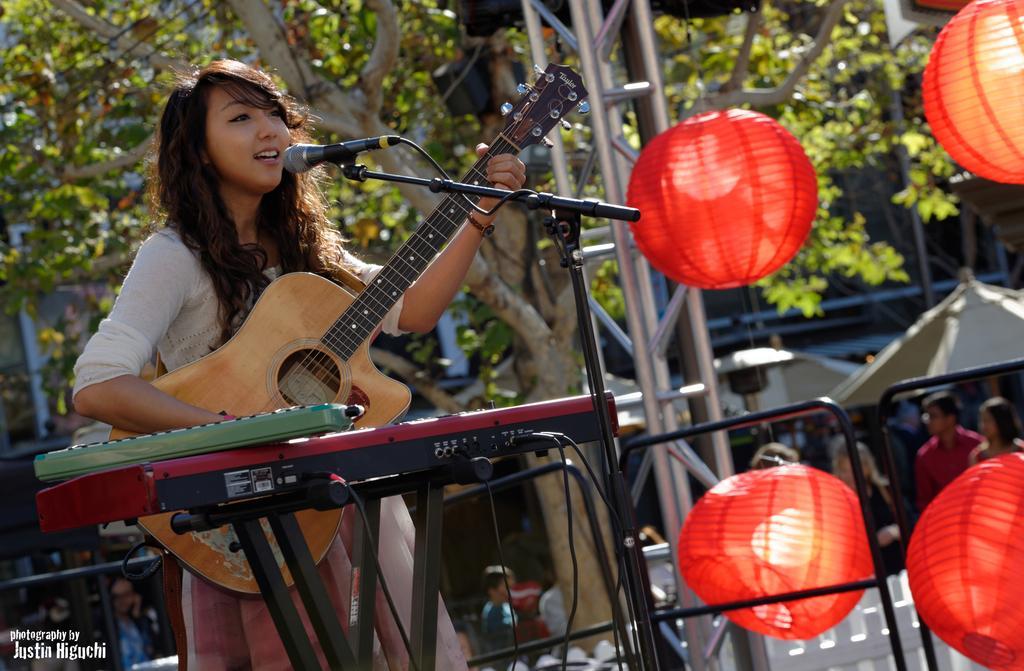In one or two sentences, can you explain what this image depicts? In this image I can see a woman wearing white color t-shirt. She's holding guitar in her hands and it seems like she's singing a song. In front of her there is a mike stand. In the background I can some trees. On the right bottom of the side there are some persons. On the right side I can see four red color balloons. In front of her there is a table and on that there is a piano. 